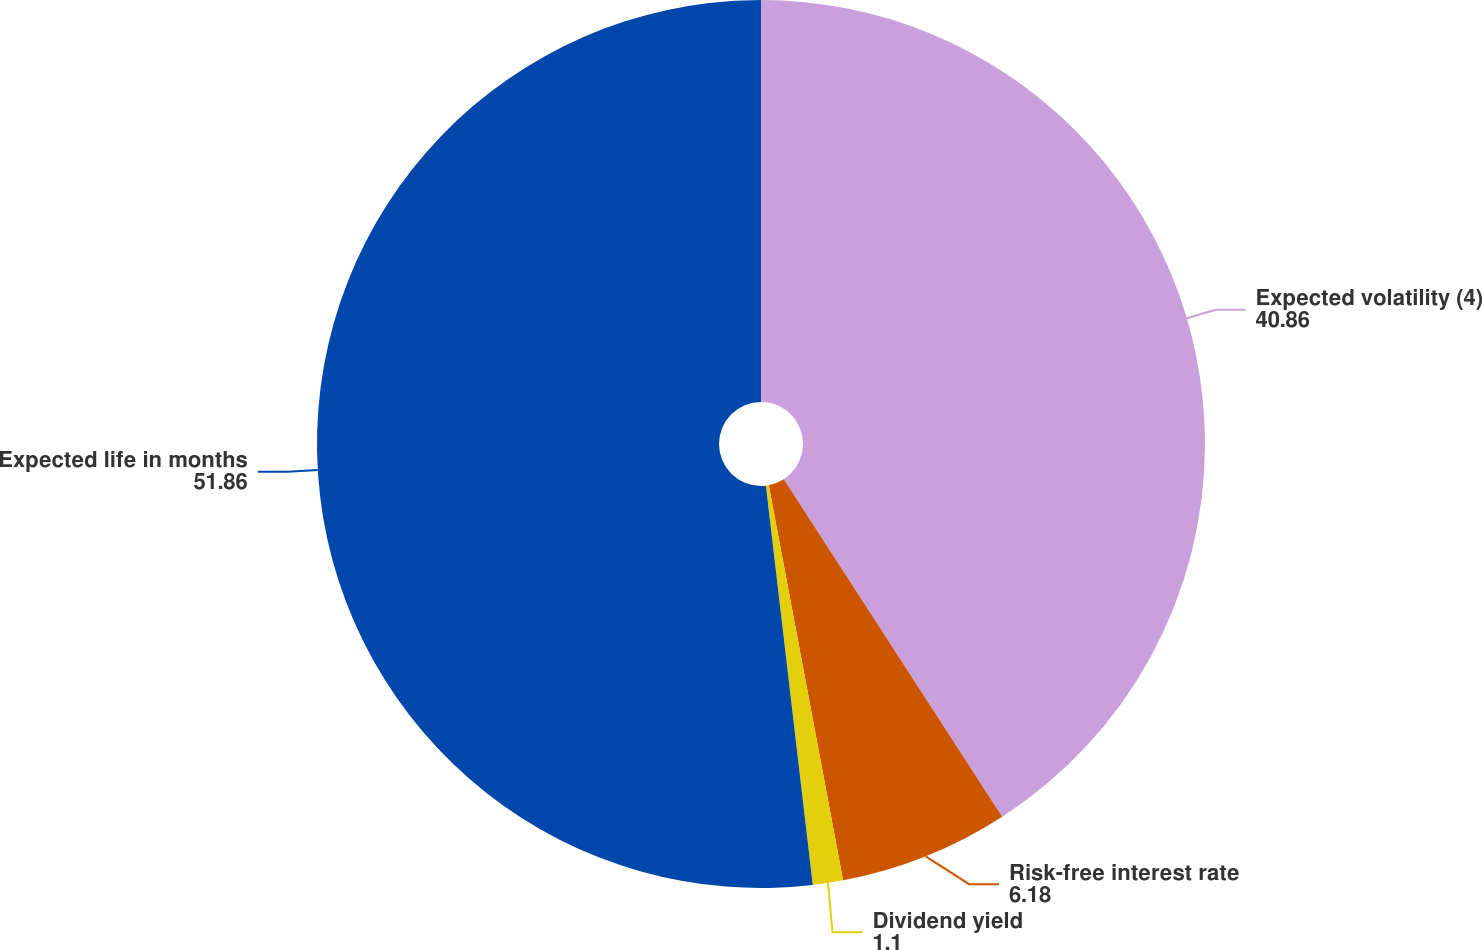Convert chart to OTSL. <chart><loc_0><loc_0><loc_500><loc_500><pie_chart><fcel>Expected volatility (4)<fcel>Risk-free interest rate<fcel>Dividend yield<fcel>Expected life in months<nl><fcel>40.86%<fcel>6.18%<fcel>1.1%<fcel>51.86%<nl></chart> 